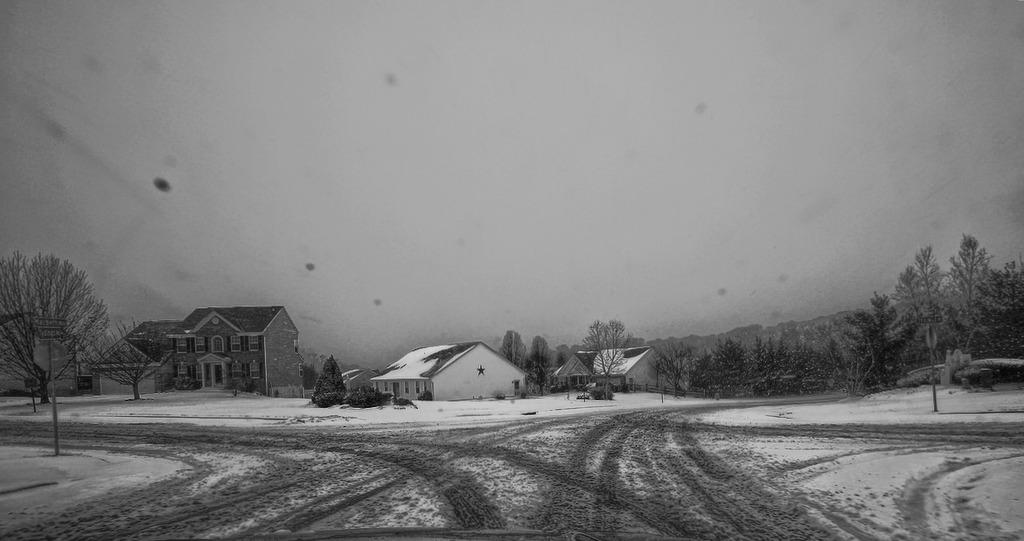What type of structures can be seen in the picture? There are houses in the picture. What other natural elements are present in the image? There are trees in the picture. What is the weather like in the picture? There is snow visible in the picture, indicating a cold and likely wintery scene. What is visible at the top of the picture? The sky is clear at the top of the picture. What type of plough can be seen in the picture? There is no plough present in the image. --- Facts: 1. There is a person in the image. 2. The person is wearing a hat. 3. The person is holding a book. 4. The person is standing in front of a bookshelf. 5. The bookshelf is filled with books. Absurd Topics: elephant, piano Conversation: Who or what is the main subject in the image? The main subject in the image is a person. What is the person wearing in the image? The person is wearing a hat in the image. What is the person holding in the image? The person is holding a book in the image. What is the person standing in front of in the image? The person is standing in front of a bookshelf in the image. What can be observed about the bookshelf in the image? The bookshelf in the image is filled with books. Reasoning: Let's think step by step in order to produce the conversation. We start by identifying the main subject of the image, which is a person. Then, we describe the person's attire, specifically mentioning the hat. Next, we observe the object the person is holding, which is a book. After that, we describe the setting where the person is standing, which is in front of a bookshelf. Finally, we describe the bookshelf's condition, which is filled with books. Absurd Question/Answer: What type of elephant can be seen playing the piano in the image? There is no elephant or piano present in the image. 